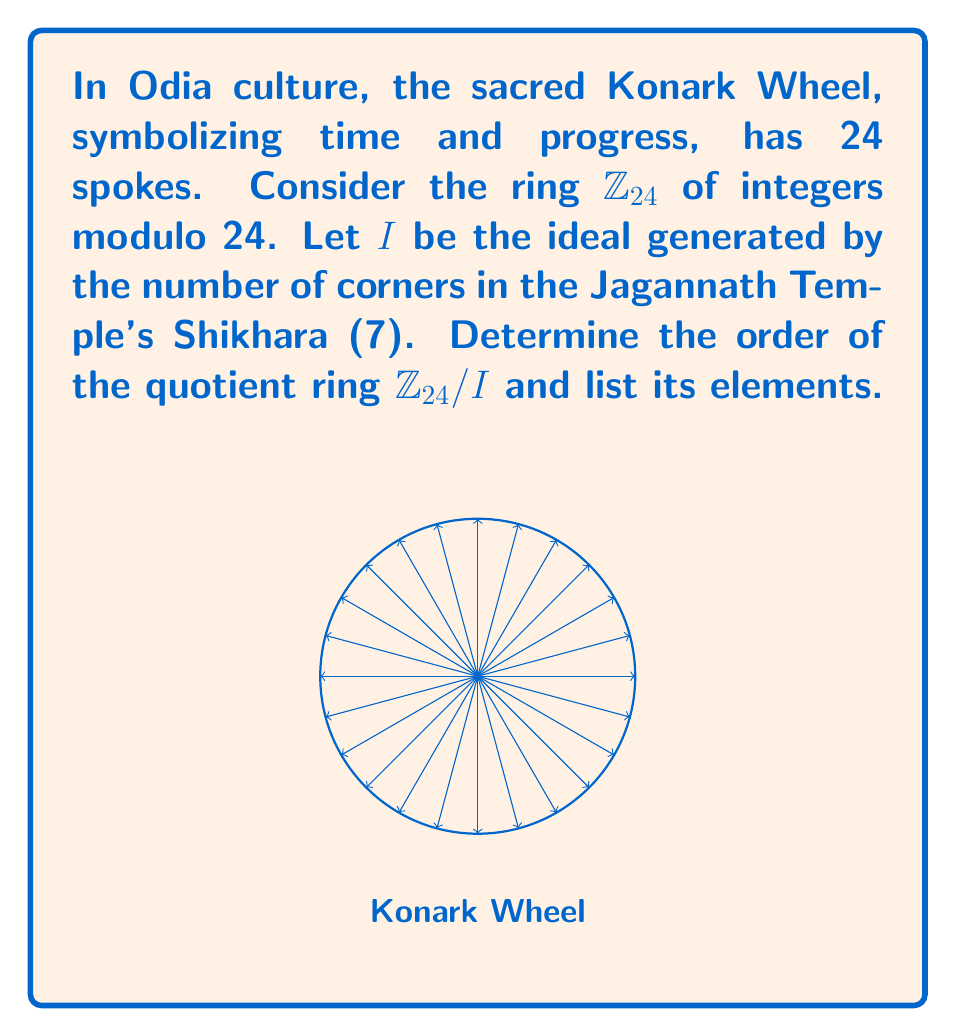Could you help me with this problem? Let's approach this step-by-step:

1) First, we need to determine the ideal $I$. In $\mathbb{Z}_{24}$, $I = \langle 7 \rangle = \{7k \mod 24 : k \in \mathbb{Z}\}$.

2) To find the elements of $I$:
   $7 \cdot 1 = 7 \mod 24$
   $7 \cdot 2 = 14 \mod 24$
   $7 \cdot 3 = 21 \mod 24$
   $7 \cdot 4 = 4 \mod 24$
   $7 \cdot 5 = 11 \mod 24$
   $7 \cdot 6 = 18 \mod 24$
   $7 \cdot 7 = 1 \mod 24$

   So, $I = \{0, 7, 14, 21, 4, 11, 18, 1\}$

3) The quotient ring $\mathbb{Z}_{24}/I$ consists of cosets of $I$ in $\mathbb{Z}_{24}$. Each coset has the form $a + I$ where $a \in \mathbb{Z}_{24}$.

4) To find the distinct cosets, we add each element of $\mathbb{Z}_{24}$ to $I$ and simplify modulo 24:

   $0 + I = I$
   $1 + I = \{1, 8, 15, 22, 5, 12, 19, 2\}$
   $2 + I = \{2, 9, 16, 23, 6, 13, 20, 3\}$

5) We continue this process and find that there are exactly 3 distinct cosets:
   $[0] = I = \{0, 7, 14, 21, 4, 11, 18, 1\}$
   $[1] = 1 + I = \{1, 8, 15, 22, 5, 12, 19, 2\}$
   $[2] = 2 + I = \{2, 9, 16, 23, 6, 13, 20, 3\}$

6) The order of the quotient ring is the number of distinct cosets, which is 3.

7) Therefore, $\mathbb{Z}_{24}/I \cong \mathbb{Z}_3$, and its elements are $\{[0], [1], [2]\}$.
Answer: Order: 3; Elements: $\{[0], [1], [2]\}$ 